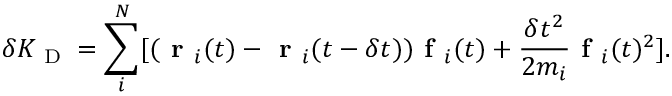Convert formula to latex. <formula><loc_0><loc_0><loc_500><loc_500>\delta K _ { D } = \sum _ { i } ^ { N } [ ( r _ { i } ( t ) - r _ { i } ( t - \delta t ) ) f _ { i } ( t ) + \frac { \delta t ^ { 2 } } { 2 m _ { i } } f _ { i } ( t ) ^ { 2 } ] .</formula> 